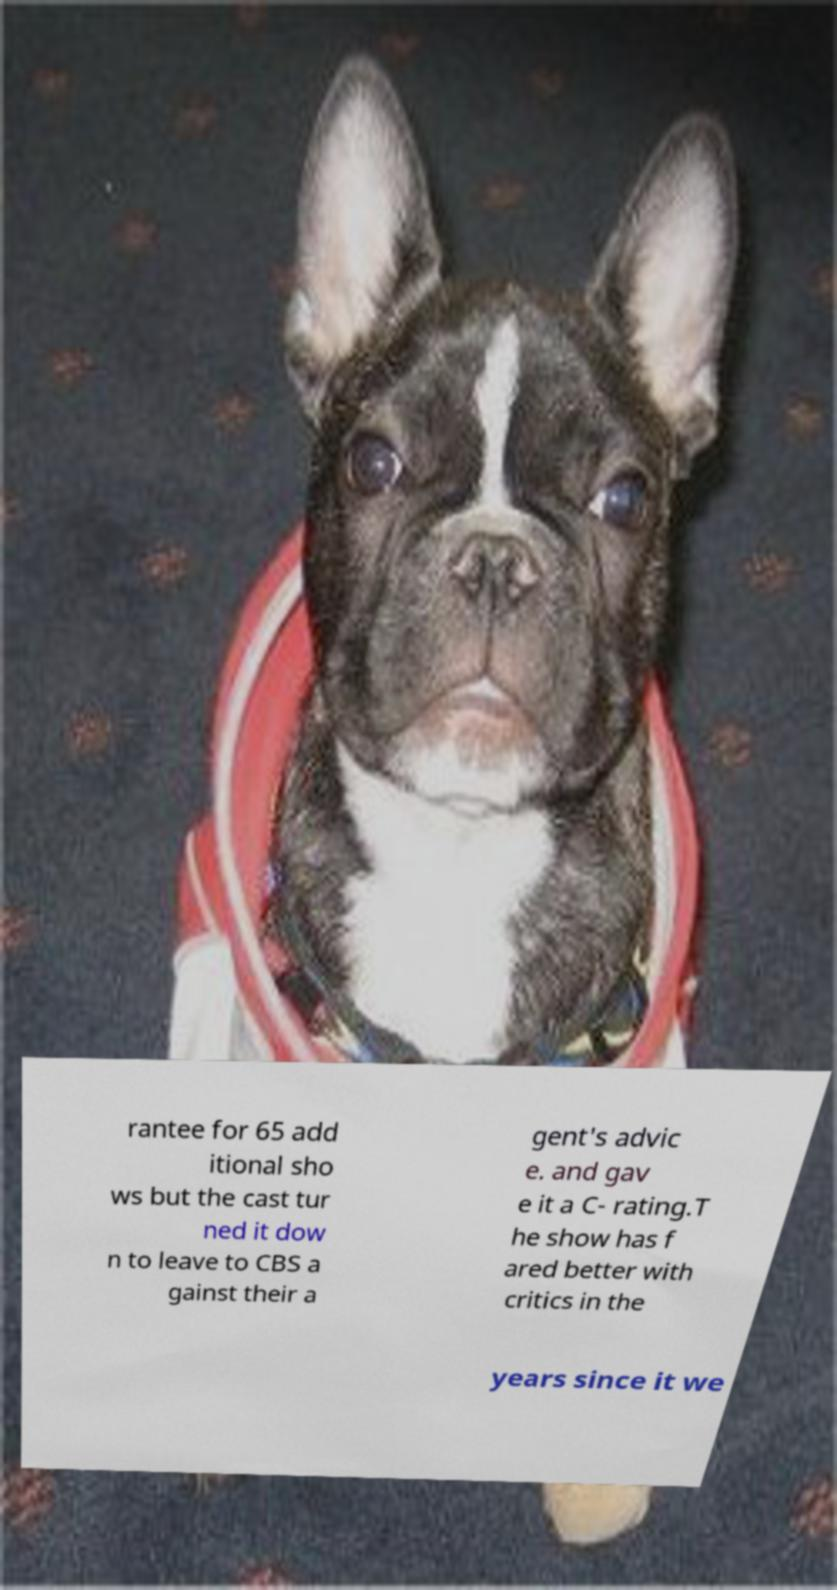Can you accurately transcribe the text from the provided image for me? rantee for 65 add itional sho ws but the cast tur ned it dow n to leave to CBS a gainst their a gent's advic e. and gav e it a C- rating.T he show has f ared better with critics in the years since it we 